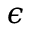Convert formula to latex. <formula><loc_0><loc_0><loc_500><loc_500>\epsilon</formula> 